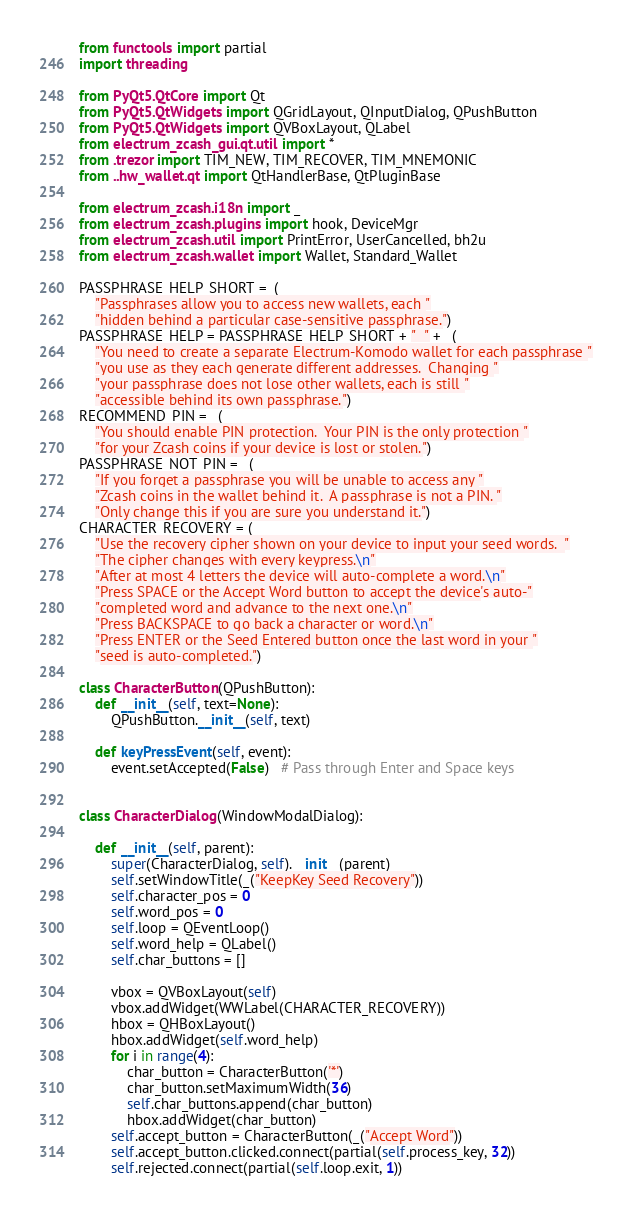<code> <loc_0><loc_0><loc_500><loc_500><_Python_>from functools import partial
import threading

from PyQt5.QtCore import Qt
from PyQt5.QtWidgets import QGridLayout, QInputDialog, QPushButton
from PyQt5.QtWidgets import QVBoxLayout, QLabel
from electrum_zcash_gui.qt.util import *
from .trezor import TIM_NEW, TIM_RECOVER, TIM_MNEMONIC
from ..hw_wallet.qt import QtHandlerBase, QtPluginBase

from electrum_zcash.i18n import _
from electrum_zcash.plugins import hook, DeviceMgr
from electrum_zcash.util import PrintError, UserCancelled, bh2u
from electrum_zcash.wallet import Wallet, Standard_Wallet

PASSPHRASE_HELP_SHORT =_(
    "Passphrases allow you to access new wallets, each "
    "hidden behind a particular case-sensitive passphrase.")
PASSPHRASE_HELP = PASSPHRASE_HELP_SHORT + "  " + _(
    "You need to create a separate Electrum-Komodo wallet for each passphrase "
    "you use as they each generate different addresses.  Changing "
    "your passphrase does not lose other wallets, each is still "
    "accessible behind its own passphrase.")
RECOMMEND_PIN = _(
    "You should enable PIN protection.  Your PIN is the only protection "
    "for your Zcash coins if your device is lost or stolen.")
PASSPHRASE_NOT_PIN = _(
    "If you forget a passphrase you will be unable to access any "
    "Zcash coins in the wallet behind it.  A passphrase is not a PIN. "
    "Only change this if you are sure you understand it.")
CHARACTER_RECOVERY = (
    "Use the recovery cipher shown on your device to input your seed words.  "
    "The cipher changes with every keypress.\n"
    "After at most 4 letters the device will auto-complete a word.\n"
    "Press SPACE or the Accept Word button to accept the device's auto-"
    "completed word and advance to the next one.\n"
    "Press BACKSPACE to go back a character or word.\n"
    "Press ENTER or the Seed Entered button once the last word in your "
    "seed is auto-completed.")

class CharacterButton(QPushButton):
    def __init__(self, text=None):
        QPushButton.__init__(self, text)

    def keyPressEvent(self, event):
        event.setAccepted(False)   # Pass through Enter and Space keys


class CharacterDialog(WindowModalDialog):

    def __init__(self, parent):
        super(CharacterDialog, self).__init__(parent)
        self.setWindowTitle(_("KeepKey Seed Recovery"))
        self.character_pos = 0
        self.word_pos = 0
        self.loop = QEventLoop()
        self.word_help = QLabel()
        self.char_buttons = []

        vbox = QVBoxLayout(self)
        vbox.addWidget(WWLabel(CHARACTER_RECOVERY))
        hbox = QHBoxLayout()
        hbox.addWidget(self.word_help)
        for i in range(4):
            char_button = CharacterButton('*')
            char_button.setMaximumWidth(36)
            self.char_buttons.append(char_button)
            hbox.addWidget(char_button)
        self.accept_button = CharacterButton(_("Accept Word"))
        self.accept_button.clicked.connect(partial(self.process_key, 32))
        self.rejected.connect(partial(self.loop.exit, 1))</code> 